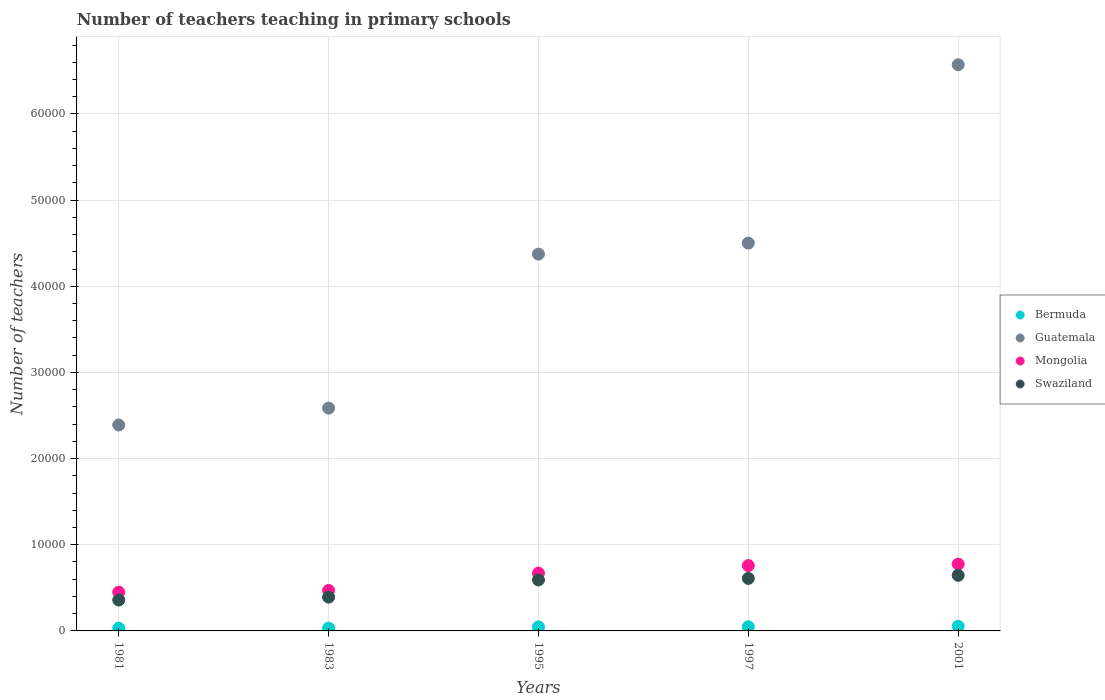How many different coloured dotlines are there?
Offer a very short reply. 4. Is the number of dotlines equal to the number of legend labels?
Provide a short and direct response. Yes. What is the number of teachers teaching in primary schools in Bermuda in 1983?
Provide a short and direct response. 322. Across all years, what is the maximum number of teachers teaching in primary schools in Mongolia?
Your response must be concise. 7755. Across all years, what is the minimum number of teachers teaching in primary schools in Guatemala?
Keep it short and to the point. 2.39e+04. In which year was the number of teachers teaching in primary schools in Guatemala maximum?
Give a very brief answer. 2001. What is the total number of teachers teaching in primary schools in Swaziland in the graph?
Offer a very short reply. 2.60e+04. What is the difference between the number of teachers teaching in primary schools in Mongolia in 1983 and that in 2001?
Keep it short and to the point. -3055. What is the difference between the number of teachers teaching in primary schools in Guatemala in 1983 and the number of teachers teaching in primary schools in Bermuda in 1981?
Keep it short and to the point. 2.56e+04. What is the average number of teachers teaching in primary schools in Mongolia per year?
Give a very brief answer. 6248.4. In the year 1983, what is the difference between the number of teachers teaching in primary schools in Bermuda and number of teachers teaching in primary schools in Guatemala?
Provide a short and direct response. -2.55e+04. What is the ratio of the number of teachers teaching in primary schools in Swaziland in 1997 to that in 2001?
Ensure brevity in your answer.  0.94. Is the difference between the number of teachers teaching in primary schools in Bermuda in 1981 and 2001 greater than the difference between the number of teachers teaching in primary schools in Guatemala in 1981 and 2001?
Offer a terse response. Yes. What is the difference between the highest and the second highest number of teachers teaching in primary schools in Bermuda?
Keep it short and to the point. 58. What is the difference between the highest and the lowest number of teachers teaching in primary schools in Bermuda?
Your answer should be compact. 224. In how many years, is the number of teachers teaching in primary schools in Bermuda greater than the average number of teachers teaching in primary schools in Bermuda taken over all years?
Ensure brevity in your answer.  3. Does the number of teachers teaching in primary schools in Guatemala monotonically increase over the years?
Provide a succinct answer. Yes. Is the number of teachers teaching in primary schools in Bermuda strictly greater than the number of teachers teaching in primary schools in Guatemala over the years?
Offer a very short reply. No. How many dotlines are there?
Provide a succinct answer. 4. How many years are there in the graph?
Keep it short and to the point. 5. Are the values on the major ticks of Y-axis written in scientific E-notation?
Give a very brief answer. No. Does the graph contain any zero values?
Offer a terse response. No. Where does the legend appear in the graph?
Keep it short and to the point. Center right. What is the title of the graph?
Ensure brevity in your answer.  Number of teachers teaching in primary schools. What is the label or title of the Y-axis?
Keep it short and to the point. Number of teachers. What is the Number of teachers of Bermuda in 1981?
Your response must be concise. 312. What is the Number of teachers in Guatemala in 1981?
Provide a succinct answer. 2.39e+04. What is the Number of teachers in Mongolia in 1981?
Keep it short and to the point. 4496. What is the Number of teachers in Swaziland in 1981?
Keep it short and to the point. 3586. What is the Number of teachers in Bermuda in 1983?
Provide a succinct answer. 322. What is the Number of teachers in Guatemala in 1983?
Offer a terse response. 2.59e+04. What is the Number of teachers of Mongolia in 1983?
Offer a very short reply. 4700. What is the Number of teachers in Swaziland in 1983?
Your response must be concise. 3922. What is the Number of teachers of Bermuda in 1995?
Keep it short and to the point. 463. What is the Number of teachers in Guatemala in 1995?
Make the answer very short. 4.37e+04. What is the Number of teachers in Mongolia in 1995?
Offer a very short reply. 6704. What is the Number of teachers in Swaziland in 1995?
Your answer should be very brief. 5917. What is the Number of teachers of Bermuda in 1997?
Provide a short and direct response. 478. What is the Number of teachers in Guatemala in 1997?
Provide a succinct answer. 4.50e+04. What is the Number of teachers of Mongolia in 1997?
Make the answer very short. 7587. What is the Number of teachers in Swaziland in 1997?
Your answer should be very brief. 6094. What is the Number of teachers in Bermuda in 2001?
Ensure brevity in your answer.  536. What is the Number of teachers in Guatemala in 2001?
Provide a short and direct response. 6.57e+04. What is the Number of teachers of Mongolia in 2001?
Offer a terse response. 7755. What is the Number of teachers of Swaziland in 2001?
Keep it short and to the point. 6451. Across all years, what is the maximum Number of teachers of Bermuda?
Your answer should be very brief. 536. Across all years, what is the maximum Number of teachers in Guatemala?
Make the answer very short. 6.57e+04. Across all years, what is the maximum Number of teachers of Mongolia?
Give a very brief answer. 7755. Across all years, what is the maximum Number of teachers of Swaziland?
Ensure brevity in your answer.  6451. Across all years, what is the minimum Number of teachers of Bermuda?
Provide a short and direct response. 312. Across all years, what is the minimum Number of teachers of Guatemala?
Give a very brief answer. 2.39e+04. Across all years, what is the minimum Number of teachers in Mongolia?
Ensure brevity in your answer.  4496. Across all years, what is the minimum Number of teachers of Swaziland?
Ensure brevity in your answer.  3586. What is the total Number of teachers in Bermuda in the graph?
Your answer should be compact. 2111. What is the total Number of teachers of Guatemala in the graph?
Provide a succinct answer. 2.04e+05. What is the total Number of teachers in Mongolia in the graph?
Ensure brevity in your answer.  3.12e+04. What is the total Number of teachers in Swaziland in the graph?
Your response must be concise. 2.60e+04. What is the difference between the Number of teachers of Bermuda in 1981 and that in 1983?
Give a very brief answer. -10. What is the difference between the Number of teachers of Guatemala in 1981 and that in 1983?
Keep it short and to the point. -1962. What is the difference between the Number of teachers of Mongolia in 1981 and that in 1983?
Offer a terse response. -204. What is the difference between the Number of teachers of Swaziland in 1981 and that in 1983?
Offer a very short reply. -336. What is the difference between the Number of teachers in Bermuda in 1981 and that in 1995?
Your response must be concise. -151. What is the difference between the Number of teachers of Guatemala in 1981 and that in 1995?
Ensure brevity in your answer.  -1.98e+04. What is the difference between the Number of teachers in Mongolia in 1981 and that in 1995?
Give a very brief answer. -2208. What is the difference between the Number of teachers in Swaziland in 1981 and that in 1995?
Provide a succinct answer. -2331. What is the difference between the Number of teachers of Bermuda in 1981 and that in 1997?
Your answer should be very brief. -166. What is the difference between the Number of teachers in Guatemala in 1981 and that in 1997?
Your answer should be compact. -2.11e+04. What is the difference between the Number of teachers of Mongolia in 1981 and that in 1997?
Make the answer very short. -3091. What is the difference between the Number of teachers in Swaziland in 1981 and that in 1997?
Offer a very short reply. -2508. What is the difference between the Number of teachers in Bermuda in 1981 and that in 2001?
Your answer should be compact. -224. What is the difference between the Number of teachers of Guatemala in 1981 and that in 2001?
Make the answer very short. -4.18e+04. What is the difference between the Number of teachers of Mongolia in 1981 and that in 2001?
Keep it short and to the point. -3259. What is the difference between the Number of teachers of Swaziland in 1981 and that in 2001?
Provide a short and direct response. -2865. What is the difference between the Number of teachers of Bermuda in 1983 and that in 1995?
Your answer should be very brief. -141. What is the difference between the Number of teachers of Guatemala in 1983 and that in 1995?
Your response must be concise. -1.79e+04. What is the difference between the Number of teachers of Mongolia in 1983 and that in 1995?
Ensure brevity in your answer.  -2004. What is the difference between the Number of teachers in Swaziland in 1983 and that in 1995?
Ensure brevity in your answer.  -1995. What is the difference between the Number of teachers of Bermuda in 1983 and that in 1997?
Keep it short and to the point. -156. What is the difference between the Number of teachers in Guatemala in 1983 and that in 1997?
Keep it short and to the point. -1.91e+04. What is the difference between the Number of teachers of Mongolia in 1983 and that in 1997?
Keep it short and to the point. -2887. What is the difference between the Number of teachers in Swaziland in 1983 and that in 1997?
Provide a succinct answer. -2172. What is the difference between the Number of teachers of Bermuda in 1983 and that in 2001?
Your answer should be compact. -214. What is the difference between the Number of teachers in Guatemala in 1983 and that in 2001?
Offer a very short reply. -3.98e+04. What is the difference between the Number of teachers of Mongolia in 1983 and that in 2001?
Keep it short and to the point. -3055. What is the difference between the Number of teachers of Swaziland in 1983 and that in 2001?
Your answer should be very brief. -2529. What is the difference between the Number of teachers of Bermuda in 1995 and that in 1997?
Your response must be concise. -15. What is the difference between the Number of teachers in Guatemala in 1995 and that in 1997?
Your answer should be compact. -1279. What is the difference between the Number of teachers in Mongolia in 1995 and that in 1997?
Make the answer very short. -883. What is the difference between the Number of teachers of Swaziland in 1995 and that in 1997?
Make the answer very short. -177. What is the difference between the Number of teachers of Bermuda in 1995 and that in 2001?
Your response must be concise. -73. What is the difference between the Number of teachers of Guatemala in 1995 and that in 2001?
Provide a succinct answer. -2.20e+04. What is the difference between the Number of teachers in Mongolia in 1995 and that in 2001?
Provide a succinct answer. -1051. What is the difference between the Number of teachers in Swaziland in 1995 and that in 2001?
Provide a short and direct response. -534. What is the difference between the Number of teachers of Bermuda in 1997 and that in 2001?
Ensure brevity in your answer.  -58. What is the difference between the Number of teachers in Guatemala in 1997 and that in 2001?
Make the answer very short. -2.07e+04. What is the difference between the Number of teachers of Mongolia in 1997 and that in 2001?
Your response must be concise. -168. What is the difference between the Number of teachers in Swaziland in 1997 and that in 2001?
Make the answer very short. -357. What is the difference between the Number of teachers in Bermuda in 1981 and the Number of teachers in Guatemala in 1983?
Your answer should be compact. -2.56e+04. What is the difference between the Number of teachers of Bermuda in 1981 and the Number of teachers of Mongolia in 1983?
Provide a short and direct response. -4388. What is the difference between the Number of teachers in Bermuda in 1981 and the Number of teachers in Swaziland in 1983?
Make the answer very short. -3610. What is the difference between the Number of teachers of Guatemala in 1981 and the Number of teachers of Mongolia in 1983?
Your answer should be very brief. 1.92e+04. What is the difference between the Number of teachers in Guatemala in 1981 and the Number of teachers in Swaziland in 1983?
Offer a terse response. 2.00e+04. What is the difference between the Number of teachers in Mongolia in 1981 and the Number of teachers in Swaziland in 1983?
Offer a very short reply. 574. What is the difference between the Number of teachers in Bermuda in 1981 and the Number of teachers in Guatemala in 1995?
Provide a succinct answer. -4.34e+04. What is the difference between the Number of teachers in Bermuda in 1981 and the Number of teachers in Mongolia in 1995?
Make the answer very short. -6392. What is the difference between the Number of teachers in Bermuda in 1981 and the Number of teachers in Swaziland in 1995?
Provide a succinct answer. -5605. What is the difference between the Number of teachers in Guatemala in 1981 and the Number of teachers in Mongolia in 1995?
Your response must be concise. 1.72e+04. What is the difference between the Number of teachers in Guatemala in 1981 and the Number of teachers in Swaziland in 1995?
Make the answer very short. 1.80e+04. What is the difference between the Number of teachers in Mongolia in 1981 and the Number of teachers in Swaziland in 1995?
Your answer should be compact. -1421. What is the difference between the Number of teachers of Bermuda in 1981 and the Number of teachers of Guatemala in 1997?
Provide a succinct answer. -4.47e+04. What is the difference between the Number of teachers in Bermuda in 1981 and the Number of teachers in Mongolia in 1997?
Your response must be concise. -7275. What is the difference between the Number of teachers in Bermuda in 1981 and the Number of teachers in Swaziland in 1997?
Your answer should be compact. -5782. What is the difference between the Number of teachers of Guatemala in 1981 and the Number of teachers of Mongolia in 1997?
Make the answer very short. 1.63e+04. What is the difference between the Number of teachers of Guatemala in 1981 and the Number of teachers of Swaziland in 1997?
Offer a very short reply. 1.78e+04. What is the difference between the Number of teachers of Mongolia in 1981 and the Number of teachers of Swaziland in 1997?
Your answer should be compact. -1598. What is the difference between the Number of teachers in Bermuda in 1981 and the Number of teachers in Guatemala in 2001?
Make the answer very short. -6.54e+04. What is the difference between the Number of teachers in Bermuda in 1981 and the Number of teachers in Mongolia in 2001?
Provide a succinct answer. -7443. What is the difference between the Number of teachers of Bermuda in 1981 and the Number of teachers of Swaziland in 2001?
Keep it short and to the point. -6139. What is the difference between the Number of teachers of Guatemala in 1981 and the Number of teachers of Mongolia in 2001?
Ensure brevity in your answer.  1.61e+04. What is the difference between the Number of teachers of Guatemala in 1981 and the Number of teachers of Swaziland in 2001?
Make the answer very short. 1.74e+04. What is the difference between the Number of teachers of Mongolia in 1981 and the Number of teachers of Swaziland in 2001?
Your answer should be very brief. -1955. What is the difference between the Number of teachers of Bermuda in 1983 and the Number of teachers of Guatemala in 1995?
Keep it short and to the point. -4.34e+04. What is the difference between the Number of teachers of Bermuda in 1983 and the Number of teachers of Mongolia in 1995?
Make the answer very short. -6382. What is the difference between the Number of teachers in Bermuda in 1983 and the Number of teachers in Swaziland in 1995?
Your response must be concise. -5595. What is the difference between the Number of teachers of Guatemala in 1983 and the Number of teachers of Mongolia in 1995?
Provide a short and direct response. 1.92e+04. What is the difference between the Number of teachers of Guatemala in 1983 and the Number of teachers of Swaziland in 1995?
Make the answer very short. 1.99e+04. What is the difference between the Number of teachers of Mongolia in 1983 and the Number of teachers of Swaziland in 1995?
Provide a short and direct response. -1217. What is the difference between the Number of teachers in Bermuda in 1983 and the Number of teachers in Guatemala in 1997?
Give a very brief answer. -4.47e+04. What is the difference between the Number of teachers of Bermuda in 1983 and the Number of teachers of Mongolia in 1997?
Ensure brevity in your answer.  -7265. What is the difference between the Number of teachers in Bermuda in 1983 and the Number of teachers in Swaziland in 1997?
Provide a short and direct response. -5772. What is the difference between the Number of teachers of Guatemala in 1983 and the Number of teachers of Mongolia in 1997?
Ensure brevity in your answer.  1.83e+04. What is the difference between the Number of teachers of Guatemala in 1983 and the Number of teachers of Swaziland in 1997?
Your answer should be very brief. 1.98e+04. What is the difference between the Number of teachers in Mongolia in 1983 and the Number of teachers in Swaziland in 1997?
Offer a very short reply. -1394. What is the difference between the Number of teachers in Bermuda in 1983 and the Number of teachers in Guatemala in 2001?
Give a very brief answer. -6.54e+04. What is the difference between the Number of teachers of Bermuda in 1983 and the Number of teachers of Mongolia in 2001?
Your answer should be compact. -7433. What is the difference between the Number of teachers in Bermuda in 1983 and the Number of teachers in Swaziland in 2001?
Offer a terse response. -6129. What is the difference between the Number of teachers of Guatemala in 1983 and the Number of teachers of Mongolia in 2001?
Keep it short and to the point. 1.81e+04. What is the difference between the Number of teachers of Guatemala in 1983 and the Number of teachers of Swaziland in 2001?
Your answer should be compact. 1.94e+04. What is the difference between the Number of teachers of Mongolia in 1983 and the Number of teachers of Swaziland in 2001?
Ensure brevity in your answer.  -1751. What is the difference between the Number of teachers of Bermuda in 1995 and the Number of teachers of Guatemala in 1997?
Provide a succinct answer. -4.45e+04. What is the difference between the Number of teachers of Bermuda in 1995 and the Number of teachers of Mongolia in 1997?
Offer a terse response. -7124. What is the difference between the Number of teachers of Bermuda in 1995 and the Number of teachers of Swaziland in 1997?
Your answer should be compact. -5631. What is the difference between the Number of teachers in Guatemala in 1995 and the Number of teachers in Mongolia in 1997?
Provide a short and direct response. 3.61e+04. What is the difference between the Number of teachers in Guatemala in 1995 and the Number of teachers in Swaziland in 1997?
Your response must be concise. 3.76e+04. What is the difference between the Number of teachers in Mongolia in 1995 and the Number of teachers in Swaziland in 1997?
Give a very brief answer. 610. What is the difference between the Number of teachers of Bermuda in 1995 and the Number of teachers of Guatemala in 2001?
Your answer should be compact. -6.52e+04. What is the difference between the Number of teachers in Bermuda in 1995 and the Number of teachers in Mongolia in 2001?
Your response must be concise. -7292. What is the difference between the Number of teachers in Bermuda in 1995 and the Number of teachers in Swaziland in 2001?
Give a very brief answer. -5988. What is the difference between the Number of teachers in Guatemala in 1995 and the Number of teachers in Mongolia in 2001?
Your answer should be very brief. 3.60e+04. What is the difference between the Number of teachers of Guatemala in 1995 and the Number of teachers of Swaziland in 2001?
Give a very brief answer. 3.73e+04. What is the difference between the Number of teachers in Mongolia in 1995 and the Number of teachers in Swaziland in 2001?
Ensure brevity in your answer.  253. What is the difference between the Number of teachers in Bermuda in 1997 and the Number of teachers in Guatemala in 2001?
Ensure brevity in your answer.  -6.52e+04. What is the difference between the Number of teachers in Bermuda in 1997 and the Number of teachers in Mongolia in 2001?
Keep it short and to the point. -7277. What is the difference between the Number of teachers in Bermuda in 1997 and the Number of teachers in Swaziland in 2001?
Give a very brief answer. -5973. What is the difference between the Number of teachers of Guatemala in 1997 and the Number of teachers of Mongolia in 2001?
Give a very brief answer. 3.73e+04. What is the difference between the Number of teachers of Guatemala in 1997 and the Number of teachers of Swaziland in 2001?
Offer a very short reply. 3.86e+04. What is the difference between the Number of teachers of Mongolia in 1997 and the Number of teachers of Swaziland in 2001?
Provide a succinct answer. 1136. What is the average Number of teachers of Bermuda per year?
Your response must be concise. 422.2. What is the average Number of teachers of Guatemala per year?
Your response must be concise. 4.08e+04. What is the average Number of teachers in Mongolia per year?
Your answer should be very brief. 6248.4. What is the average Number of teachers in Swaziland per year?
Your answer should be very brief. 5194. In the year 1981, what is the difference between the Number of teachers of Bermuda and Number of teachers of Guatemala?
Make the answer very short. -2.36e+04. In the year 1981, what is the difference between the Number of teachers of Bermuda and Number of teachers of Mongolia?
Your answer should be very brief. -4184. In the year 1981, what is the difference between the Number of teachers of Bermuda and Number of teachers of Swaziland?
Provide a short and direct response. -3274. In the year 1981, what is the difference between the Number of teachers in Guatemala and Number of teachers in Mongolia?
Keep it short and to the point. 1.94e+04. In the year 1981, what is the difference between the Number of teachers in Guatemala and Number of teachers in Swaziland?
Your response must be concise. 2.03e+04. In the year 1981, what is the difference between the Number of teachers of Mongolia and Number of teachers of Swaziland?
Make the answer very short. 910. In the year 1983, what is the difference between the Number of teachers in Bermuda and Number of teachers in Guatemala?
Make the answer very short. -2.55e+04. In the year 1983, what is the difference between the Number of teachers in Bermuda and Number of teachers in Mongolia?
Your answer should be very brief. -4378. In the year 1983, what is the difference between the Number of teachers of Bermuda and Number of teachers of Swaziland?
Your answer should be very brief. -3600. In the year 1983, what is the difference between the Number of teachers of Guatemala and Number of teachers of Mongolia?
Your answer should be very brief. 2.12e+04. In the year 1983, what is the difference between the Number of teachers of Guatemala and Number of teachers of Swaziland?
Your answer should be very brief. 2.19e+04. In the year 1983, what is the difference between the Number of teachers of Mongolia and Number of teachers of Swaziland?
Your response must be concise. 778. In the year 1995, what is the difference between the Number of teachers of Bermuda and Number of teachers of Guatemala?
Give a very brief answer. -4.33e+04. In the year 1995, what is the difference between the Number of teachers of Bermuda and Number of teachers of Mongolia?
Your answer should be very brief. -6241. In the year 1995, what is the difference between the Number of teachers of Bermuda and Number of teachers of Swaziland?
Your answer should be very brief. -5454. In the year 1995, what is the difference between the Number of teachers of Guatemala and Number of teachers of Mongolia?
Your answer should be compact. 3.70e+04. In the year 1995, what is the difference between the Number of teachers in Guatemala and Number of teachers in Swaziland?
Provide a succinct answer. 3.78e+04. In the year 1995, what is the difference between the Number of teachers of Mongolia and Number of teachers of Swaziland?
Give a very brief answer. 787. In the year 1997, what is the difference between the Number of teachers in Bermuda and Number of teachers in Guatemala?
Ensure brevity in your answer.  -4.45e+04. In the year 1997, what is the difference between the Number of teachers of Bermuda and Number of teachers of Mongolia?
Ensure brevity in your answer.  -7109. In the year 1997, what is the difference between the Number of teachers in Bermuda and Number of teachers in Swaziland?
Provide a short and direct response. -5616. In the year 1997, what is the difference between the Number of teachers in Guatemala and Number of teachers in Mongolia?
Keep it short and to the point. 3.74e+04. In the year 1997, what is the difference between the Number of teachers in Guatemala and Number of teachers in Swaziland?
Make the answer very short. 3.89e+04. In the year 1997, what is the difference between the Number of teachers of Mongolia and Number of teachers of Swaziland?
Your answer should be very brief. 1493. In the year 2001, what is the difference between the Number of teachers of Bermuda and Number of teachers of Guatemala?
Ensure brevity in your answer.  -6.52e+04. In the year 2001, what is the difference between the Number of teachers in Bermuda and Number of teachers in Mongolia?
Make the answer very short. -7219. In the year 2001, what is the difference between the Number of teachers in Bermuda and Number of teachers in Swaziland?
Offer a very short reply. -5915. In the year 2001, what is the difference between the Number of teachers in Guatemala and Number of teachers in Mongolia?
Your answer should be very brief. 5.80e+04. In the year 2001, what is the difference between the Number of teachers of Guatemala and Number of teachers of Swaziland?
Provide a succinct answer. 5.93e+04. In the year 2001, what is the difference between the Number of teachers in Mongolia and Number of teachers in Swaziland?
Provide a succinct answer. 1304. What is the ratio of the Number of teachers in Bermuda in 1981 to that in 1983?
Offer a terse response. 0.97. What is the ratio of the Number of teachers of Guatemala in 1981 to that in 1983?
Your answer should be very brief. 0.92. What is the ratio of the Number of teachers of Mongolia in 1981 to that in 1983?
Keep it short and to the point. 0.96. What is the ratio of the Number of teachers in Swaziland in 1981 to that in 1983?
Your answer should be compact. 0.91. What is the ratio of the Number of teachers of Bermuda in 1981 to that in 1995?
Offer a very short reply. 0.67. What is the ratio of the Number of teachers of Guatemala in 1981 to that in 1995?
Offer a terse response. 0.55. What is the ratio of the Number of teachers of Mongolia in 1981 to that in 1995?
Keep it short and to the point. 0.67. What is the ratio of the Number of teachers of Swaziland in 1981 to that in 1995?
Your answer should be very brief. 0.61. What is the ratio of the Number of teachers in Bermuda in 1981 to that in 1997?
Your answer should be very brief. 0.65. What is the ratio of the Number of teachers in Guatemala in 1981 to that in 1997?
Offer a terse response. 0.53. What is the ratio of the Number of teachers of Mongolia in 1981 to that in 1997?
Give a very brief answer. 0.59. What is the ratio of the Number of teachers in Swaziland in 1981 to that in 1997?
Your response must be concise. 0.59. What is the ratio of the Number of teachers in Bermuda in 1981 to that in 2001?
Ensure brevity in your answer.  0.58. What is the ratio of the Number of teachers of Guatemala in 1981 to that in 2001?
Provide a succinct answer. 0.36. What is the ratio of the Number of teachers of Mongolia in 1981 to that in 2001?
Provide a short and direct response. 0.58. What is the ratio of the Number of teachers in Swaziland in 1981 to that in 2001?
Ensure brevity in your answer.  0.56. What is the ratio of the Number of teachers of Bermuda in 1983 to that in 1995?
Your answer should be very brief. 0.7. What is the ratio of the Number of teachers of Guatemala in 1983 to that in 1995?
Your response must be concise. 0.59. What is the ratio of the Number of teachers in Mongolia in 1983 to that in 1995?
Give a very brief answer. 0.7. What is the ratio of the Number of teachers of Swaziland in 1983 to that in 1995?
Offer a terse response. 0.66. What is the ratio of the Number of teachers of Bermuda in 1983 to that in 1997?
Keep it short and to the point. 0.67. What is the ratio of the Number of teachers of Guatemala in 1983 to that in 1997?
Keep it short and to the point. 0.57. What is the ratio of the Number of teachers in Mongolia in 1983 to that in 1997?
Offer a very short reply. 0.62. What is the ratio of the Number of teachers in Swaziland in 1983 to that in 1997?
Make the answer very short. 0.64. What is the ratio of the Number of teachers of Bermuda in 1983 to that in 2001?
Your answer should be very brief. 0.6. What is the ratio of the Number of teachers of Guatemala in 1983 to that in 2001?
Your response must be concise. 0.39. What is the ratio of the Number of teachers in Mongolia in 1983 to that in 2001?
Make the answer very short. 0.61. What is the ratio of the Number of teachers in Swaziland in 1983 to that in 2001?
Offer a very short reply. 0.61. What is the ratio of the Number of teachers in Bermuda in 1995 to that in 1997?
Ensure brevity in your answer.  0.97. What is the ratio of the Number of teachers in Guatemala in 1995 to that in 1997?
Offer a terse response. 0.97. What is the ratio of the Number of teachers in Mongolia in 1995 to that in 1997?
Provide a succinct answer. 0.88. What is the ratio of the Number of teachers of Bermuda in 1995 to that in 2001?
Your answer should be compact. 0.86. What is the ratio of the Number of teachers of Guatemala in 1995 to that in 2001?
Your answer should be compact. 0.67. What is the ratio of the Number of teachers of Mongolia in 1995 to that in 2001?
Provide a short and direct response. 0.86. What is the ratio of the Number of teachers of Swaziland in 1995 to that in 2001?
Your answer should be very brief. 0.92. What is the ratio of the Number of teachers in Bermuda in 1997 to that in 2001?
Ensure brevity in your answer.  0.89. What is the ratio of the Number of teachers of Guatemala in 1997 to that in 2001?
Offer a terse response. 0.69. What is the ratio of the Number of teachers of Mongolia in 1997 to that in 2001?
Offer a very short reply. 0.98. What is the ratio of the Number of teachers of Swaziland in 1997 to that in 2001?
Offer a very short reply. 0.94. What is the difference between the highest and the second highest Number of teachers in Bermuda?
Make the answer very short. 58. What is the difference between the highest and the second highest Number of teachers in Guatemala?
Make the answer very short. 2.07e+04. What is the difference between the highest and the second highest Number of teachers in Mongolia?
Your answer should be very brief. 168. What is the difference between the highest and the second highest Number of teachers of Swaziland?
Your answer should be very brief. 357. What is the difference between the highest and the lowest Number of teachers in Bermuda?
Your answer should be very brief. 224. What is the difference between the highest and the lowest Number of teachers of Guatemala?
Keep it short and to the point. 4.18e+04. What is the difference between the highest and the lowest Number of teachers in Mongolia?
Provide a succinct answer. 3259. What is the difference between the highest and the lowest Number of teachers of Swaziland?
Your response must be concise. 2865. 